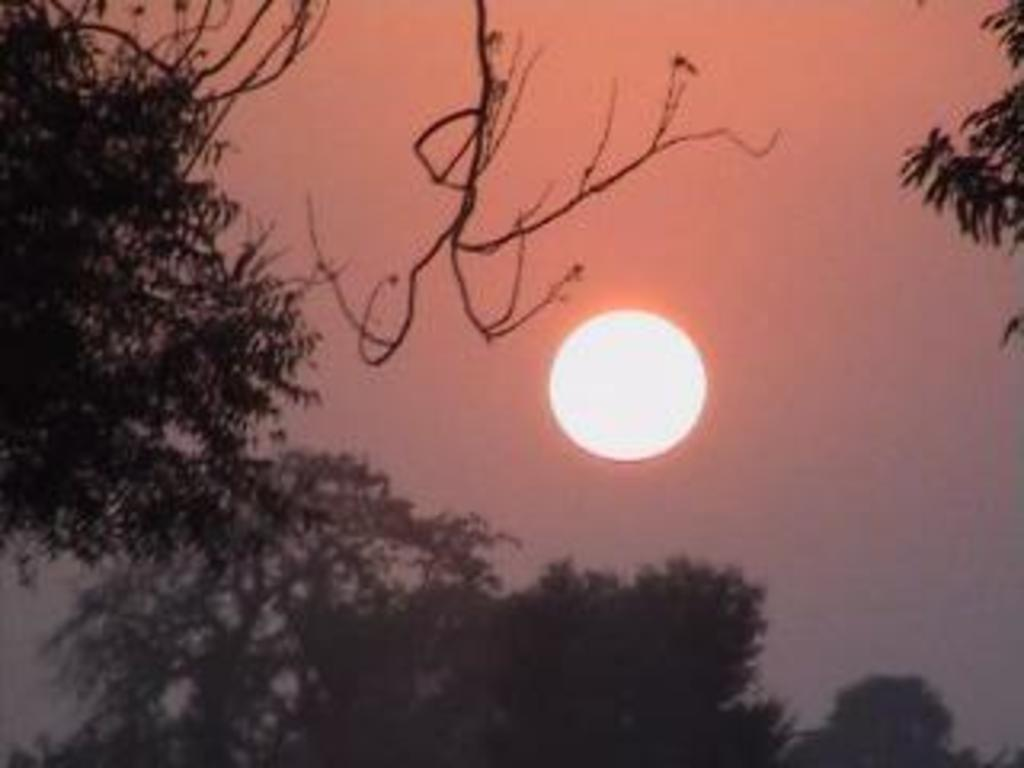What type of vegetation can be seen in the image? There are trees in the image. What is visible in the background of the image? The sky is visible in the background of the image. Can the Sun be seen in the image? Yes, the Sun is observable in the image. What type of battle is taking place in the image? There is no battle present in the image; it features trees, the sky, and the Sun. How many planes can be seen flying in the image? There are no planes visible in the image. 